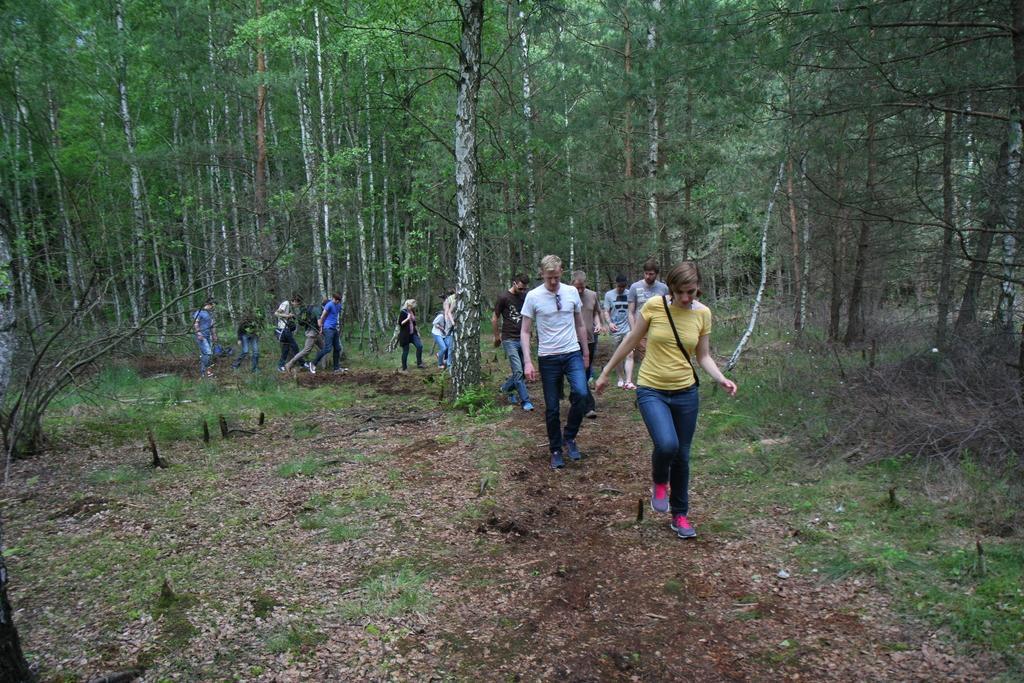Can you describe this image briefly? In this image I can see an open grass ground and on it I can see number of people are walking. I can see few of them are carrying bags and I can also see number of trees. 